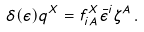Convert formula to latex. <formula><loc_0><loc_0><loc_500><loc_500>\delta ( \epsilon ) q ^ { X } = f ^ { X } _ { i A } \bar { \epsilon } ^ { i } \zeta ^ { A } \, .</formula> 